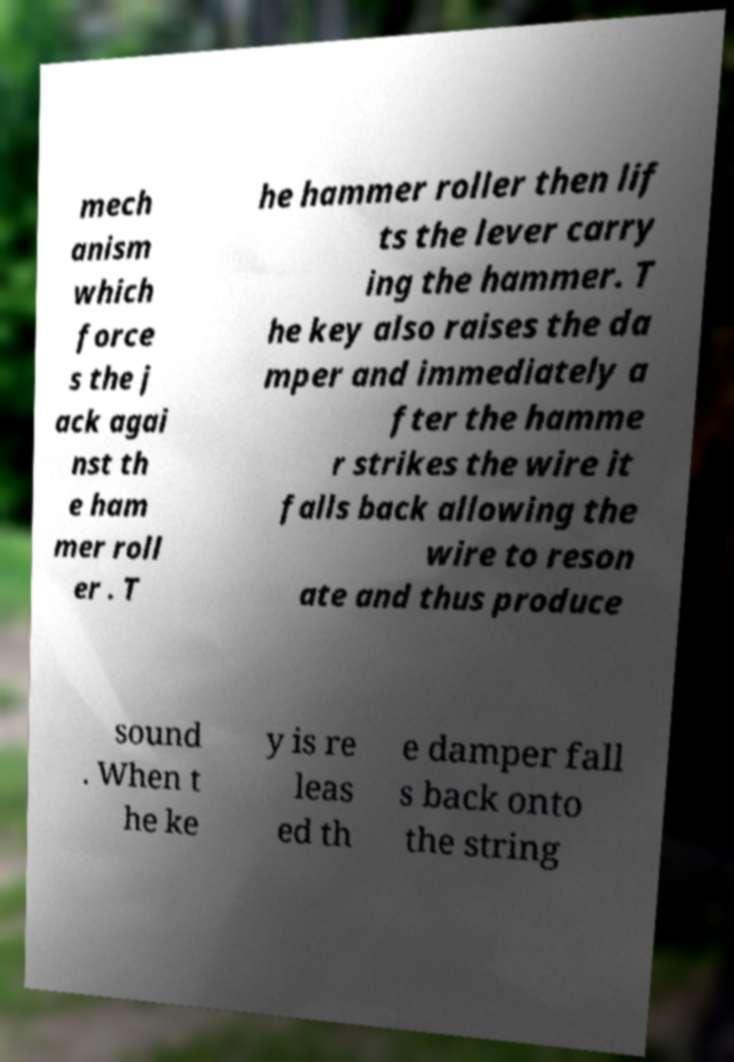Please identify and transcribe the text found in this image. mech anism which force s the j ack agai nst th e ham mer roll er . T he hammer roller then lif ts the lever carry ing the hammer. T he key also raises the da mper and immediately a fter the hamme r strikes the wire it falls back allowing the wire to reson ate and thus produce sound . When t he ke y is re leas ed th e damper fall s back onto the string 